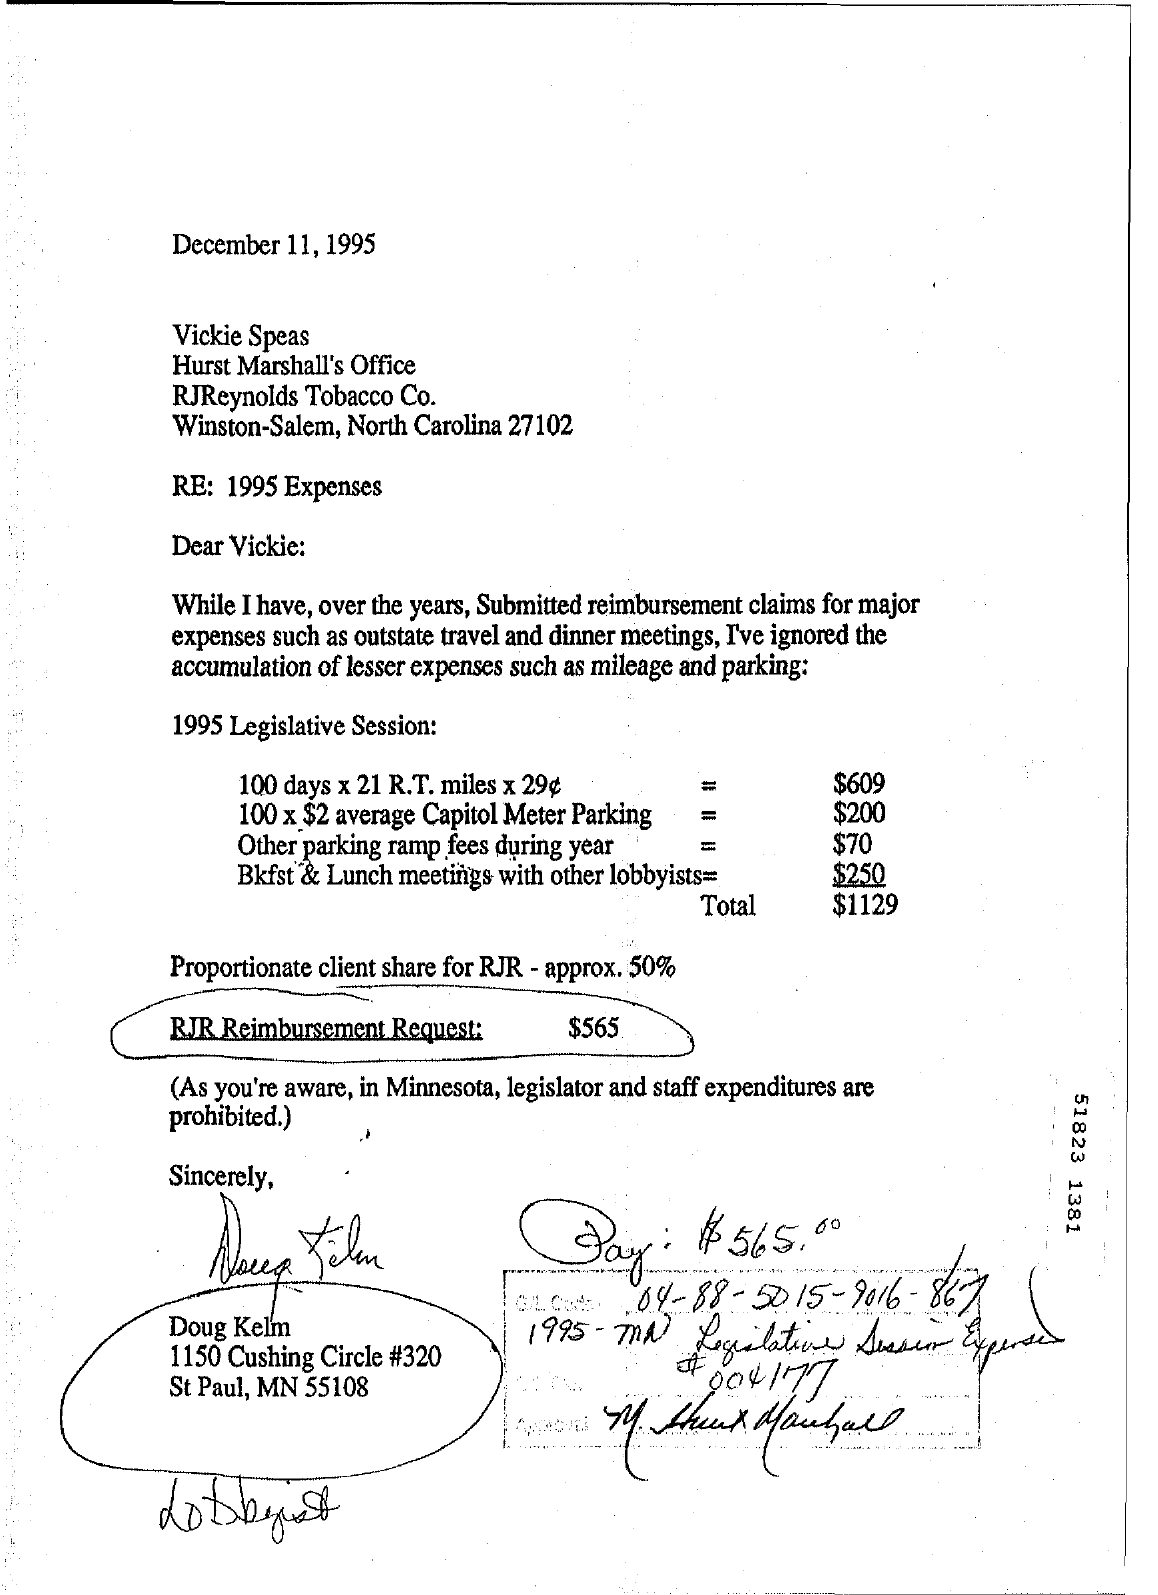When is the letter dated?
Provide a short and direct response. December 11, 1995. To whom is the letter addressed?
Provide a succinct answer. Vickie. How much is the RJR Reimbursement Request?
Your answer should be compact. $565. From whom is the letter?
Provide a succinct answer. DOUG KELM. 